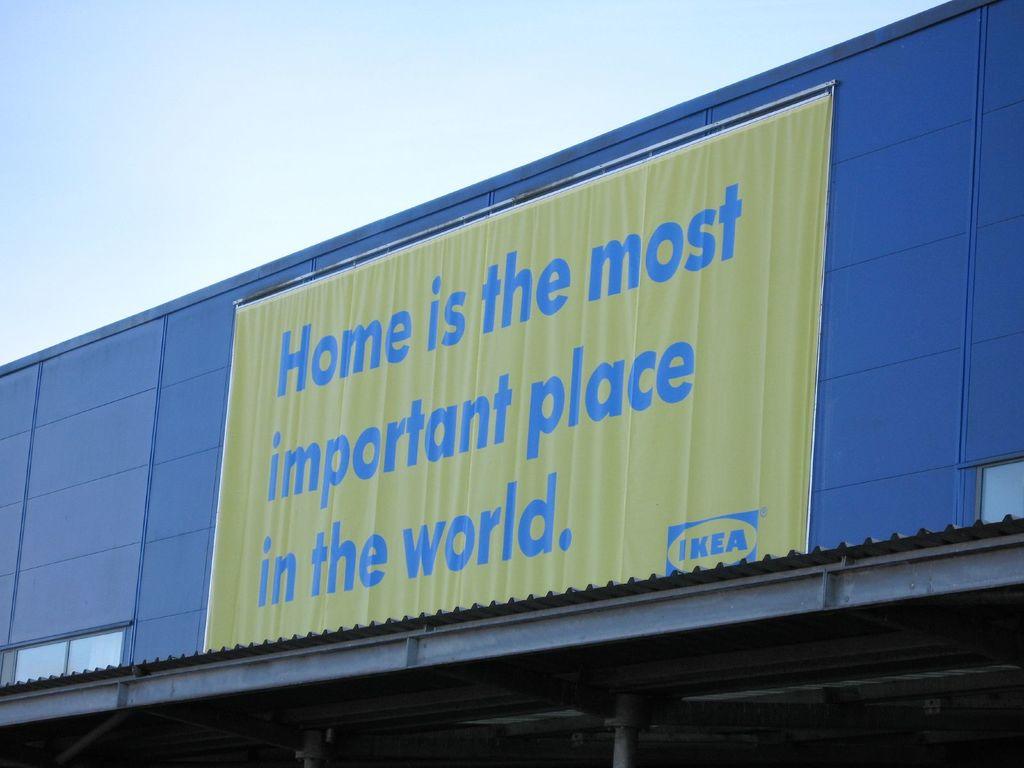What is the ikea slogan?
Your answer should be compact. Home is the most important place in the world. 